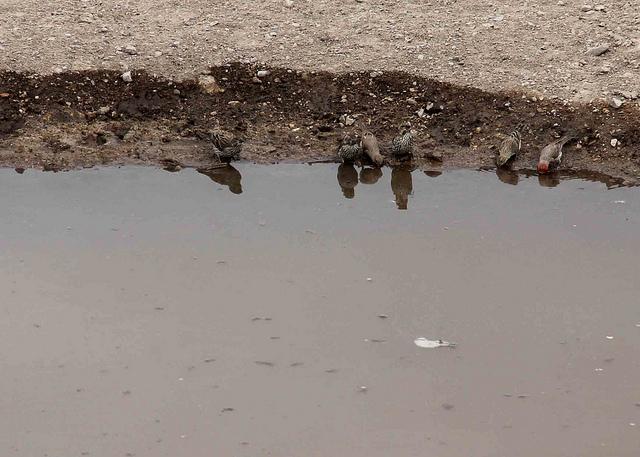Where are reflections?
Short answer required. In water. Where are the birds?
Keep it brief. Water. What is drinking water?
Give a very brief answer. Birds. How many birds are at the watering hole?
Keep it brief. 6. 